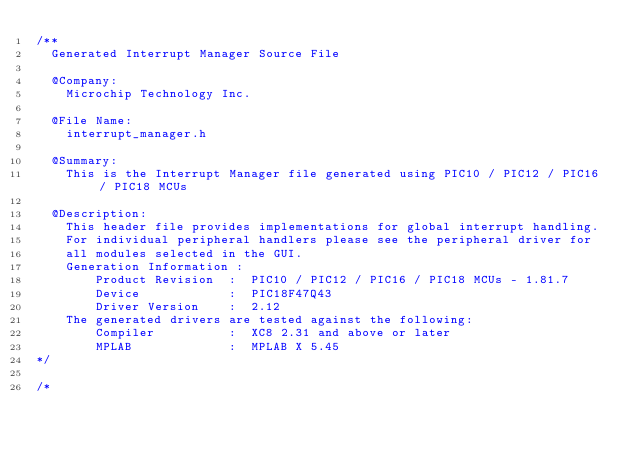<code> <loc_0><loc_0><loc_500><loc_500><_C_>/**
  Generated Interrupt Manager Source File

  @Company:
    Microchip Technology Inc.

  @File Name:
    interrupt_manager.h

  @Summary:
    This is the Interrupt Manager file generated using PIC10 / PIC12 / PIC16 / PIC18 MCUs

  @Description:
    This header file provides implementations for global interrupt handling.
    For individual peripheral handlers please see the peripheral driver for
    all modules selected in the GUI.
    Generation Information :
        Product Revision  :  PIC10 / PIC12 / PIC16 / PIC18 MCUs - 1.81.7
        Device            :  PIC18F47Q43
        Driver Version    :  2.12
    The generated drivers are tested against the following:
        Compiler          :  XC8 2.31 and above or later
        MPLAB 	          :  MPLAB X 5.45
*/

/*</code> 